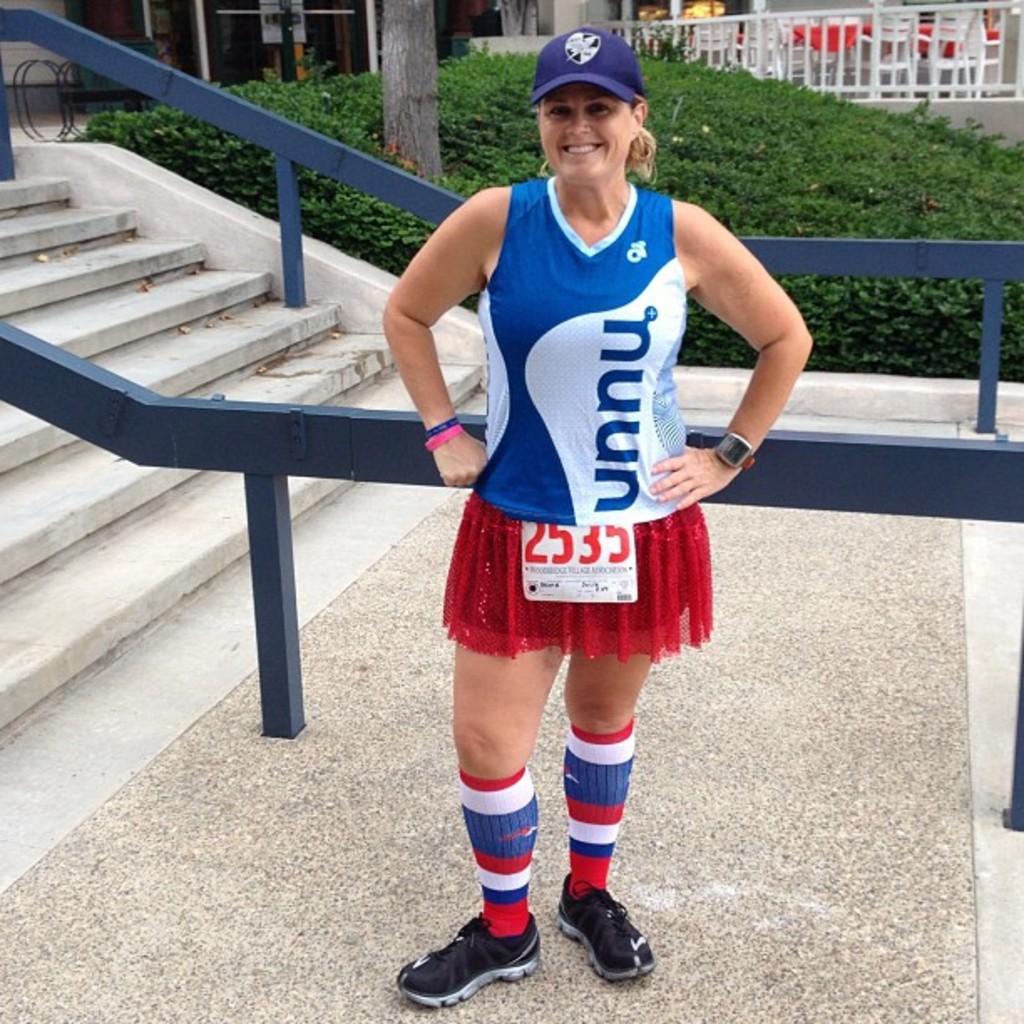What number does this runner have?
Ensure brevity in your answer.  2535. 